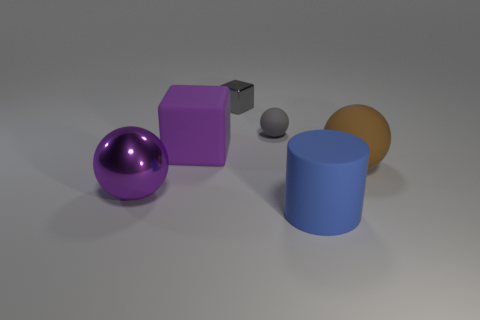Add 2 small gray metallic blocks. How many objects exist? 8 Subtract all cubes. How many objects are left? 4 Subtract all tiny brown metal spheres. Subtract all rubber objects. How many objects are left? 2 Add 5 big purple matte things. How many big purple matte things are left? 6 Add 3 small purple matte cylinders. How many small purple matte cylinders exist? 3 Subtract 0 brown cubes. How many objects are left? 6 